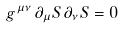<formula> <loc_0><loc_0><loc_500><loc_500>g ^ { \mu \nu } \, { \partial _ { \mu } S } \, { \partial _ { \nu } S } = 0</formula> 